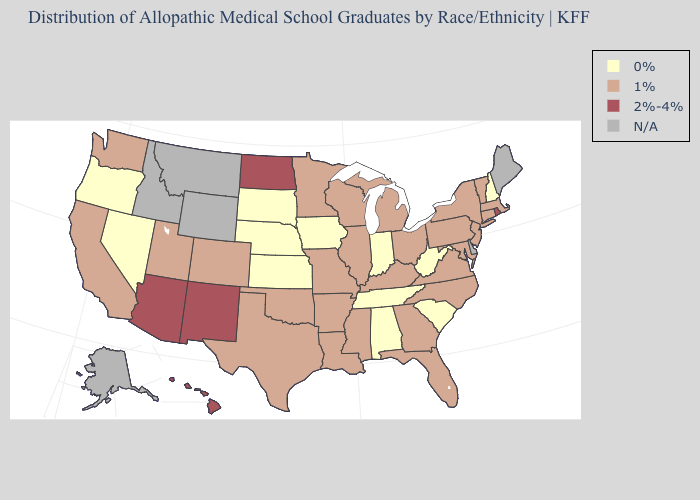What is the highest value in states that border North Carolina?
Write a very short answer. 1%. Which states hav the highest value in the West?
Concise answer only. Arizona, Hawaii, New Mexico. What is the value of Iowa?
Short answer required. 0%. Name the states that have a value in the range N/A?
Write a very short answer. Alaska, Delaware, Idaho, Maine, Montana, Wyoming. Does Maryland have the lowest value in the South?
Concise answer only. No. Name the states that have a value in the range 1%?
Answer briefly. Arkansas, California, Colorado, Connecticut, Florida, Georgia, Illinois, Kentucky, Louisiana, Maryland, Massachusetts, Michigan, Minnesota, Mississippi, Missouri, New Jersey, New York, North Carolina, Ohio, Oklahoma, Pennsylvania, Texas, Utah, Vermont, Virginia, Washington, Wisconsin. Name the states that have a value in the range 1%?
Short answer required. Arkansas, California, Colorado, Connecticut, Florida, Georgia, Illinois, Kentucky, Louisiana, Maryland, Massachusetts, Michigan, Minnesota, Mississippi, Missouri, New Jersey, New York, North Carolina, Ohio, Oklahoma, Pennsylvania, Texas, Utah, Vermont, Virginia, Washington, Wisconsin. What is the value of Louisiana?
Keep it brief. 1%. Does Arizona have the highest value in the USA?
Keep it brief. Yes. Name the states that have a value in the range 0%?
Be succinct. Alabama, Indiana, Iowa, Kansas, Nebraska, Nevada, New Hampshire, Oregon, South Carolina, South Dakota, Tennessee, West Virginia. What is the value of Delaware?
Keep it brief. N/A. What is the value of North Dakota?
Quick response, please. 2%-4%. What is the value of Ohio?
Give a very brief answer. 1%. How many symbols are there in the legend?
Write a very short answer. 4. 